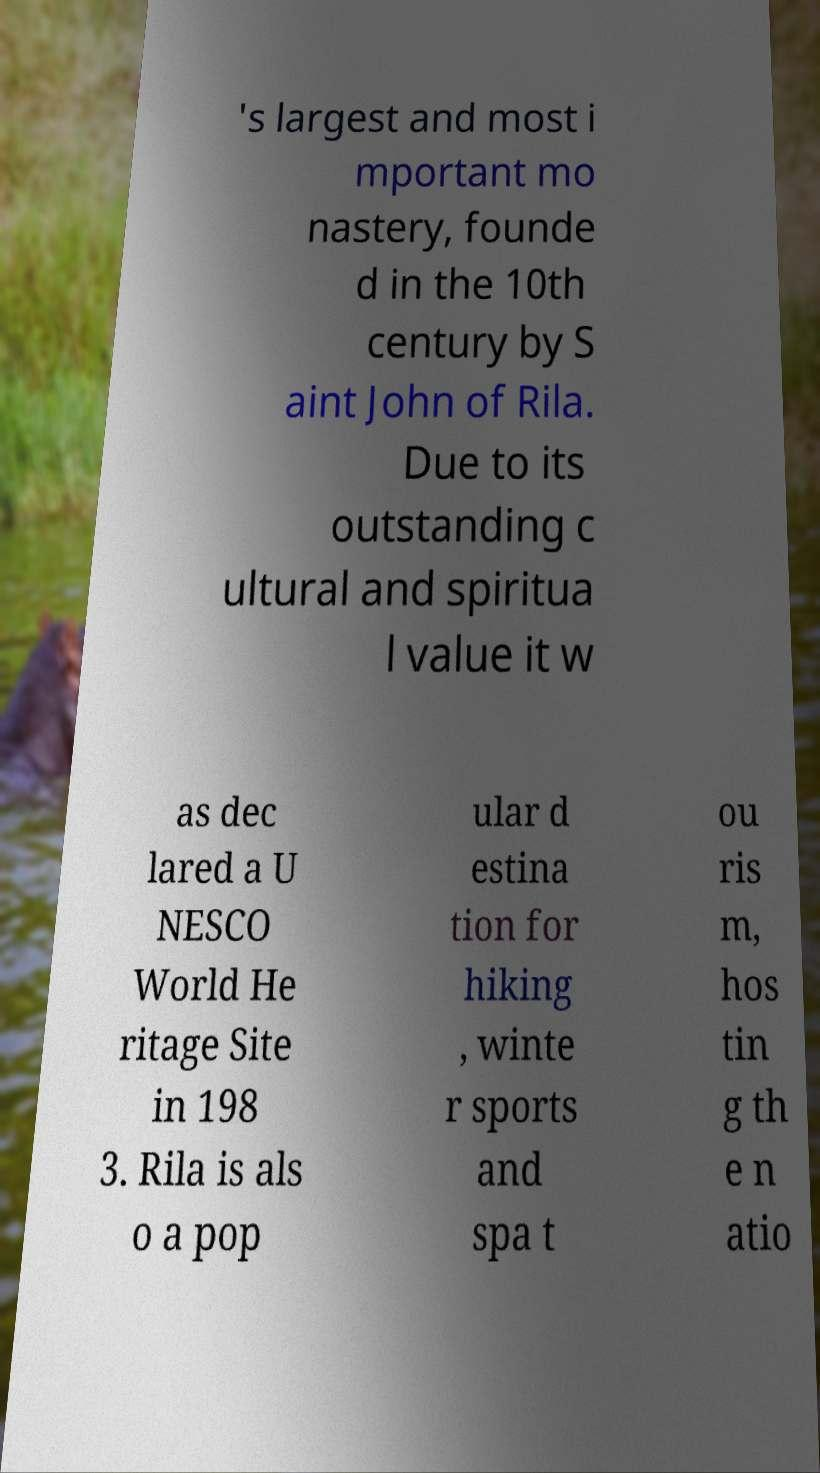Could you assist in decoding the text presented in this image and type it out clearly? 's largest and most i mportant mo nastery, founde d in the 10th century by S aint John of Rila. Due to its outstanding c ultural and spiritua l value it w as dec lared a U NESCO World He ritage Site in 198 3. Rila is als o a pop ular d estina tion for hiking , winte r sports and spa t ou ris m, hos tin g th e n atio 